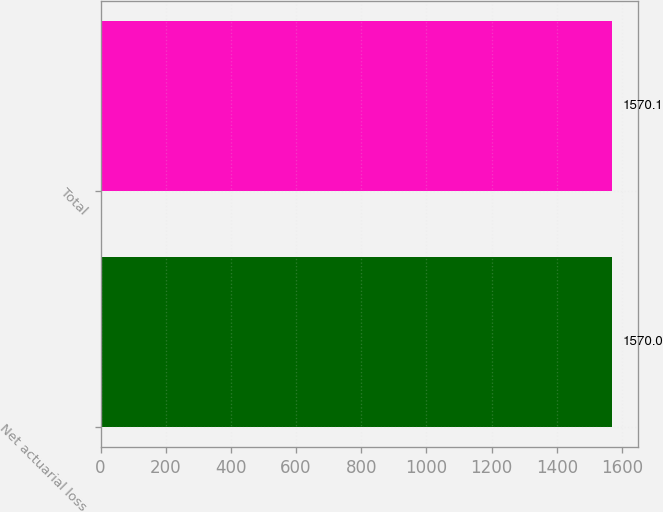<chart> <loc_0><loc_0><loc_500><loc_500><bar_chart><fcel>Net actuarial loss<fcel>Total<nl><fcel>1570<fcel>1570.1<nl></chart> 